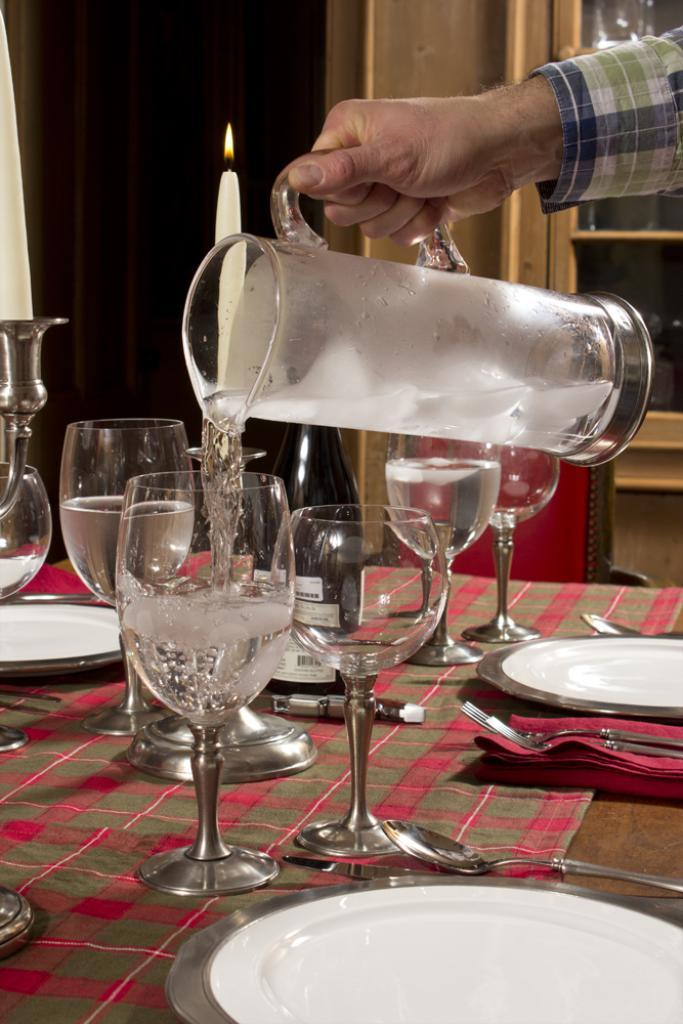What piece of furniture is visible in the image? There is a table in the image. What items are on the table? On the table, there are glasses, plates, spoons, and forks. Can you describe the man in the image? In the top right side of the image, a man is holding a jar. What type of mint is the man chewing in the image? There is no mint present in the image; the man is holding a jar. What is the root of the tree that is growing on the table? There is no tree or root present on the table; the table has glasses, plates, spoons, and forks. 